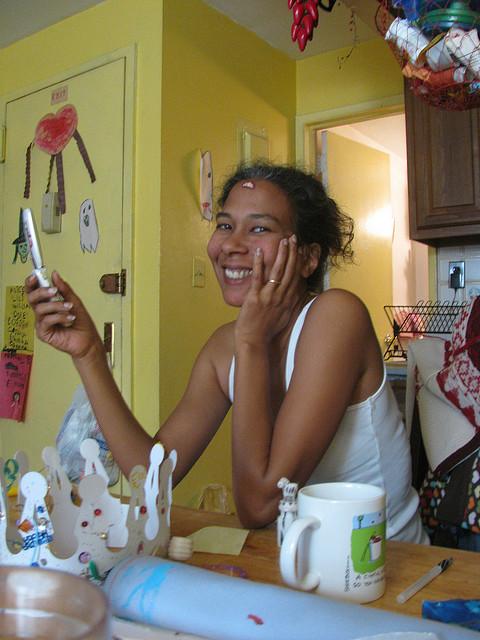Does this woman have manicured nails?
Answer briefly. Yes. Is there a cup?
Short answer required. Yes. Is this a man or a woman?
Be succinct. Woman. 